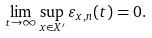Convert formula to latex. <formula><loc_0><loc_0><loc_500><loc_500>\lim _ { t \to \infty } \sup _ { x \in X ^ { \prime } } \varepsilon _ { x , n } ( t ) = 0 .</formula> 